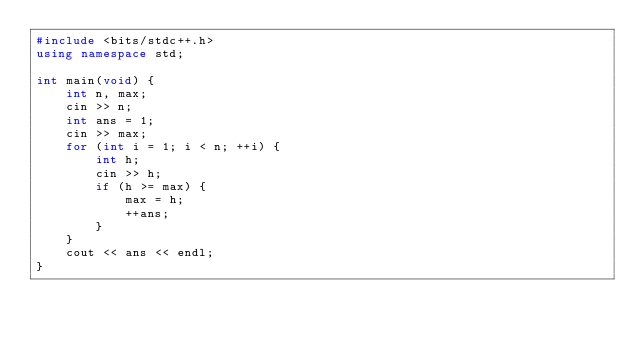Convert code to text. <code><loc_0><loc_0><loc_500><loc_500><_C++_>#include <bits/stdc++.h>
using namespace std;

int main(void) {
    int n, max;
    cin >> n;
    int ans = 1;
    cin >> max;
    for (int i = 1; i < n; ++i) {
        int h;
        cin >> h;
        if (h >= max) {
            max = h;
            ++ans;
        }
    }
    cout << ans << endl;
}
</code> 